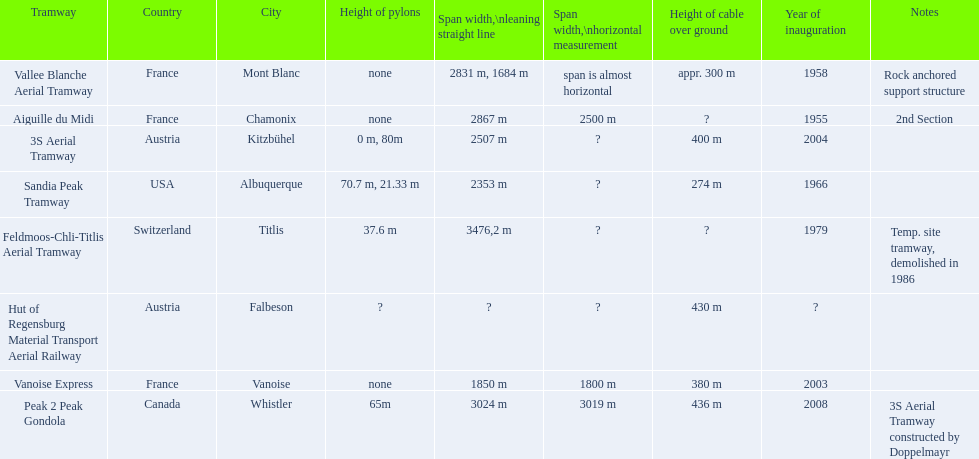Which tramway was inaugurated first, the 3s aerial tramway or the aiguille du midi? Aiguille du Midi. 